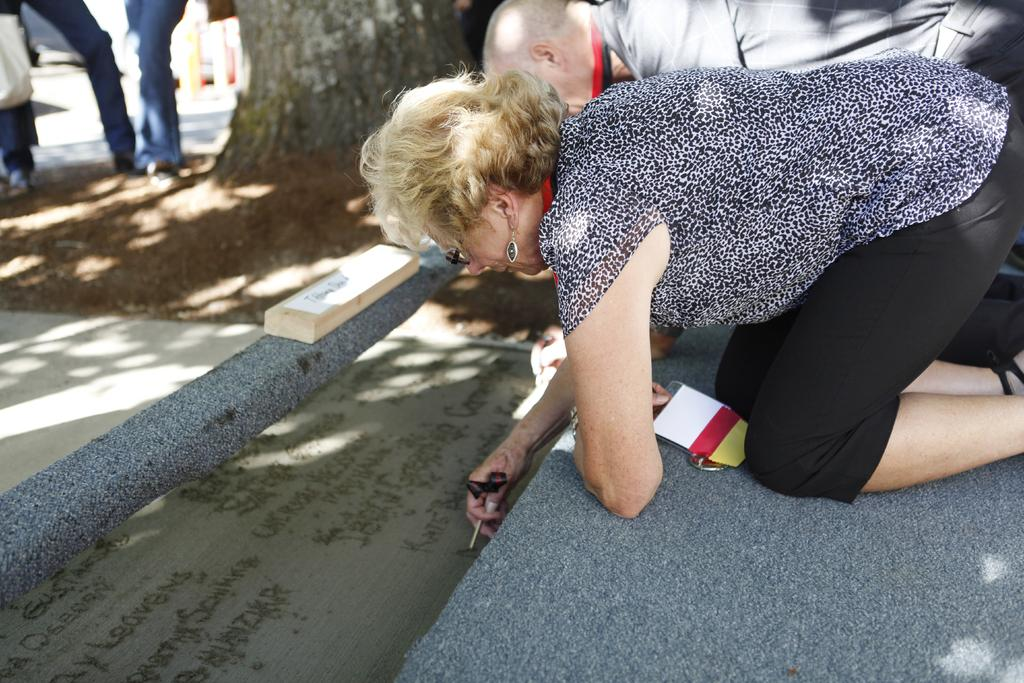How many people are in the image? There are two people in the image, a woman and a man. What are the woman and the man doing in the image? Both the woman and the man are bending, and they are writing on the floor. What can be seen in the background of the image? There is a tree in the background of the image. Are there any other people visible in the image? Yes, there are people standing near the tree. What type of air is being used by the woman and the man to write on the floor? There is no air being used by the woman and the man to write on the floor; they are likely using a writing instrument like a pen or a marker. What kind of quilt is being used by the people standing near the tree? There is no quilt present in the image; the people standing near the tree are not using any quilts. 